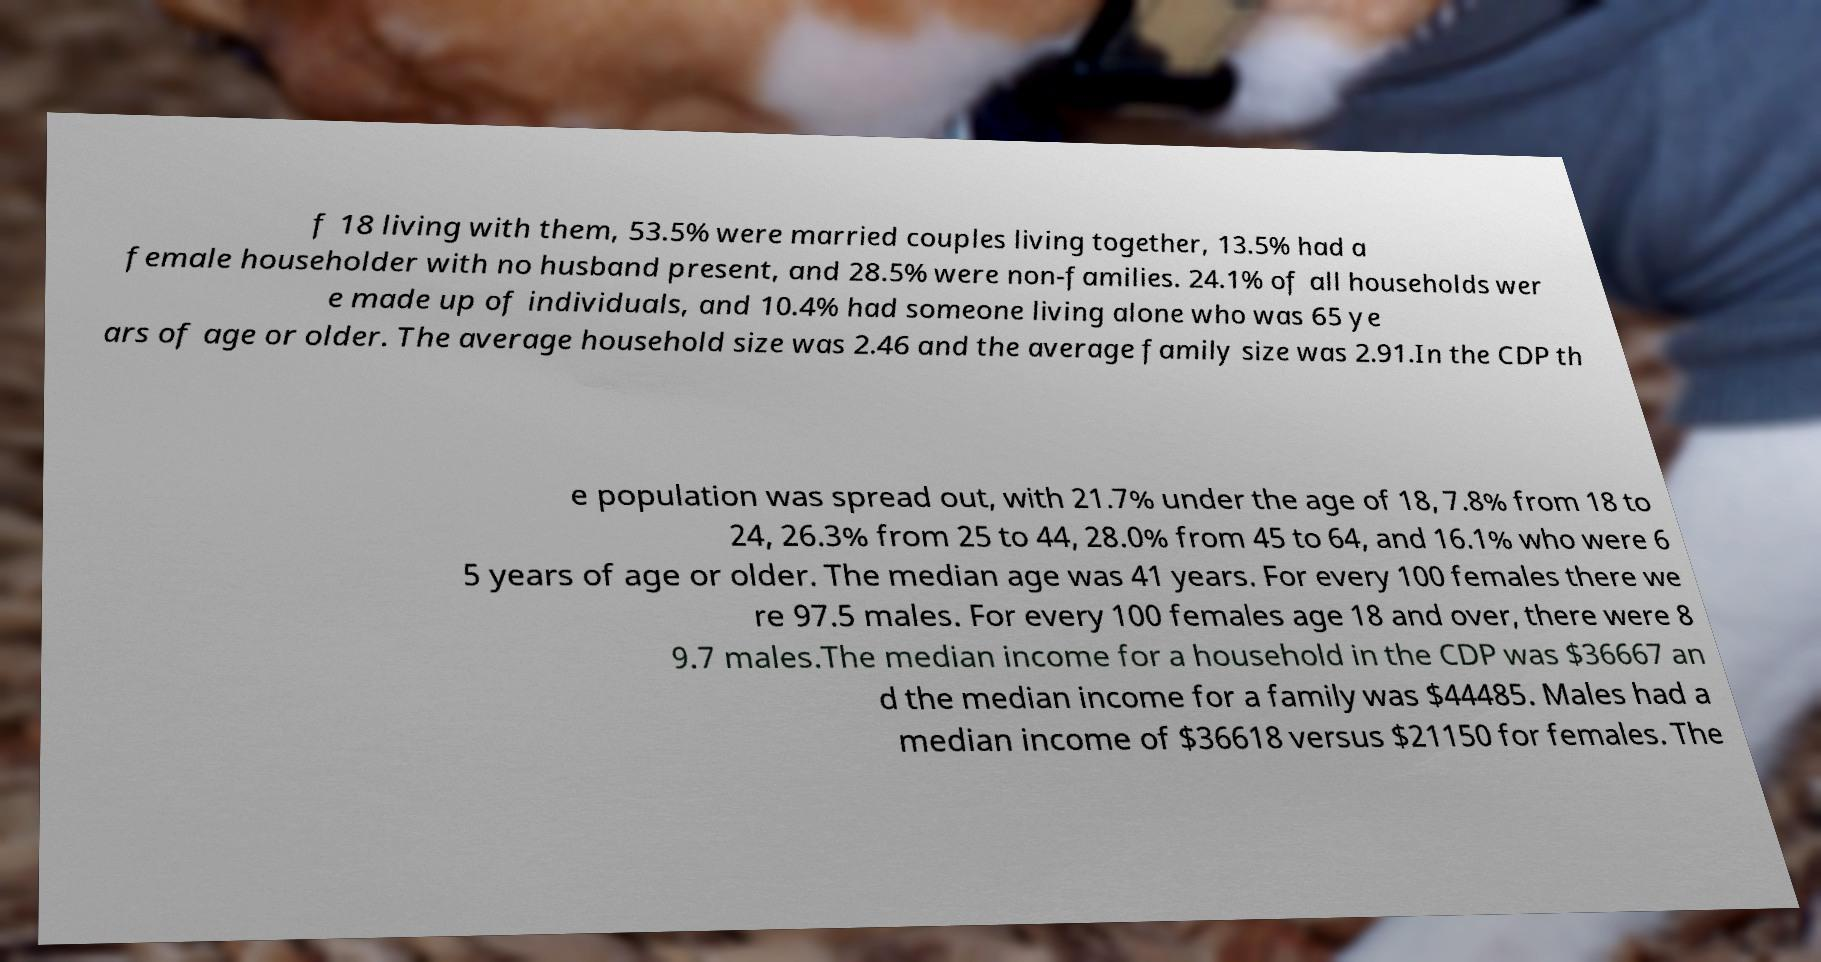There's text embedded in this image that I need extracted. Can you transcribe it verbatim? f 18 living with them, 53.5% were married couples living together, 13.5% had a female householder with no husband present, and 28.5% were non-families. 24.1% of all households wer e made up of individuals, and 10.4% had someone living alone who was 65 ye ars of age or older. The average household size was 2.46 and the average family size was 2.91.In the CDP th e population was spread out, with 21.7% under the age of 18, 7.8% from 18 to 24, 26.3% from 25 to 44, 28.0% from 45 to 64, and 16.1% who were 6 5 years of age or older. The median age was 41 years. For every 100 females there we re 97.5 males. For every 100 females age 18 and over, there were 8 9.7 males.The median income for a household in the CDP was $36667 an d the median income for a family was $44485. Males had a median income of $36618 versus $21150 for females. The 